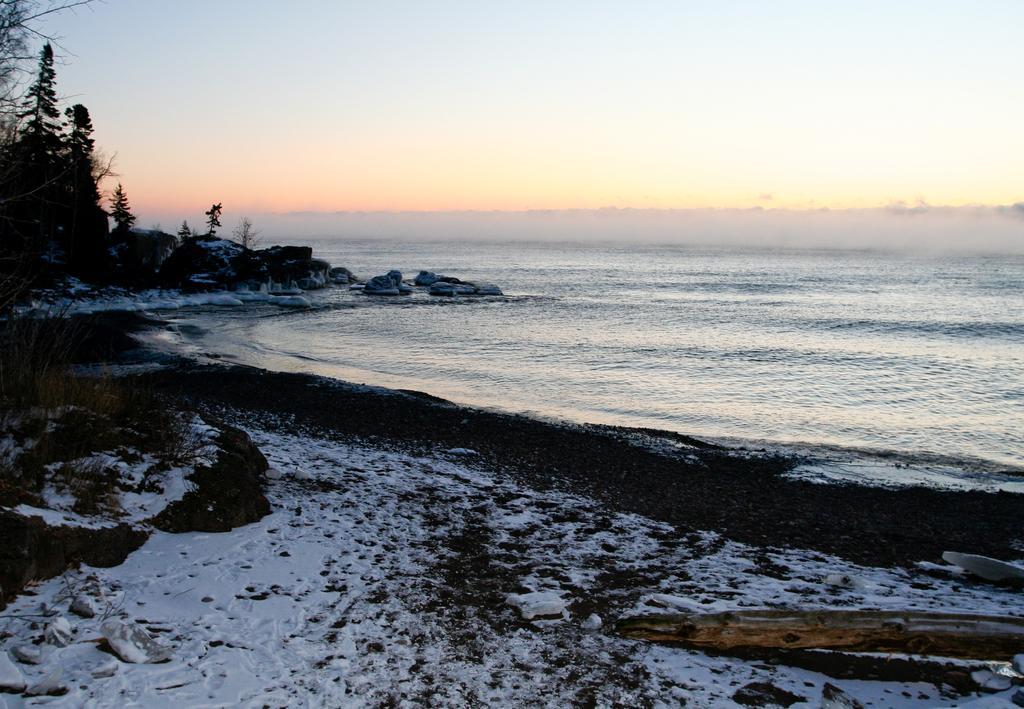Can you describe this image briefly? In this image I can see the water. In the background I can see few trees and the sky is in blue and white color. 